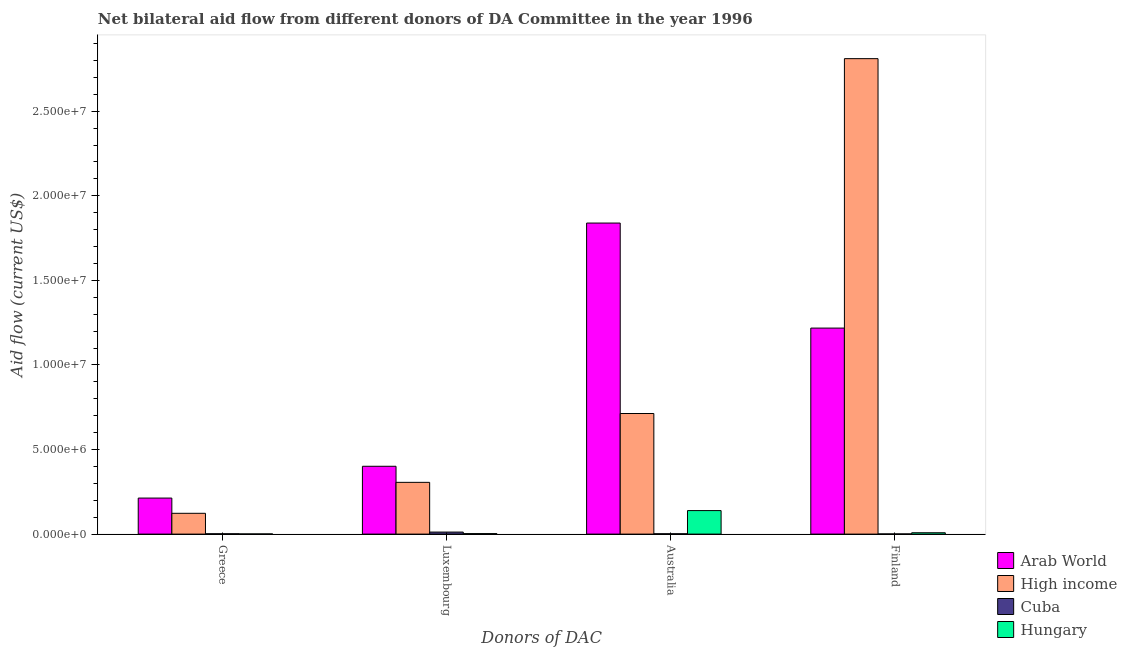Are the number of bars on each tick of the X-axis equal?
Your answer should be very brief. Yes. How many bars are there on the 3rd tick from the right?
Offer a very short reply. 4. What is the label of the 4th group of bars from the left?
Make the answer very short. Finland. What is the amount of aid given by australia in Hungary?
Provide a succinct answer. 1.39e+06. Across all countries, what is the maximum amount of aid given by luxembourg?
Your response must be concise. 4.01e+06. Across all countries, what is the minimum amount of aid given by finland?
Your answer should be compact. 10000. In which country was the amount of aid given by australia maximum?
Offer a terse response. Arab World. In which country was the amount of aid given by australia minimum?
Offer a terse response. Cuba. What is the total amount of aid given by greece in the graph?
Ensure brevity in your answer.  3.39e+06. What is the difference between the amount of aid given by finland in Arab World and that in Hungary?
Your response must be concise. 1.21e+07. What is the difference between the amount of aid given by australia in Cuba and the amount of aid given by greece in High income?
Offer a very short reply. -1.21e+06. What is the average amount of aid given by luxembourg per country?
Provide a short and direct response. 1.80e+06. What is the difference between the amount of aid given by luxembourg and amount of aid given by greece in Arab World?
Provide a short and direct response. 1.88e+06. What is the ratio of the amount of aid given by australia in High income to that in Cuba?
Provide a succinct answer. 356.5. Is the difference between the amount of aid given by finland in Hungary and High income greater than the difference between the amount of aid given by greece in Hungary and High income?
Provide a succinct answer. No. What is the difference between the highest and the second highest amount of aid given by finland?
Provide a succinct answer. 1.59e+07. What is the difference between the highest and the lowest amount of aid given by finland?
Your answer should be very brief. 2.81e+07. In how many countries, is the amount of aid given by greece greater than the average amount of aid given by greece taken over all countries?
Your answer should be compact. 2. Is the sum of the amount of aid given by australia in Arab World and Hungary greater than the maximum amount of aid given by greece across all countries?
Provide a short and direct response. Yes. Is it the case that in every country, the sum of the amount of aid given by luxembourg and amount of aid given by australia is greater than the sum of amount of aid given by greece and amount of aid given by finland?
Ensure brevity in your answer.  No. What does the 4th bar from the right in Finland represents?
Your response must be concise. Arab World. Is it the case that in every country, the sum of the amount of aid given by greece and amount of aid given by luxembourg is greater than the amount of aid given by australia?
Your answer should be very brief. No. How many bars are there?
Offer a terse response. 16. Are all the bars in the graph horizontal?
Your answer should be very brief. No. Does the graph contain grids?
Make the answer very short. No. Where does the legend appear in the graph?
Your answer should be very brief. Bottom right. How are the legend labels stacked?
Your response must be concise. Vertical. What is the title of the graph?
Give a very brief answer. Net bilateral aid flow from different donors of DA Committee in the year 1996. What is the label or title of the X-axis?
Ensure brevity in your answer.  Donors of DAC. What is the label or title of the Y-axis?
Give a very brief answer. Aid flow (current US$). What is the Aid flow (current US$) in Arab World in Greece?
Give a very brief answer. 2.13e+06. What is the Aid flow (current US$) of High income in Greece?
Your answer should be very brief. 1.23e+06. What is the Aid flow (current US$) in Hungary in Greece?
Your answer should be compact. 10000. What is the Aid flow (current US$) of Arab World in Luxembourg?
Give a very brief answer. 4.01e+06. What is the Aid flow (current US$) in High income in Luxembourg?
Ensure brevity in your answer.  3.06e+06. What is the Aid flow (current US$) of Cuba in Luxembourg?
Make the answer very short. 1.20e+05. What is the Aid flow (current US$) in Arab World in Australia?
Ensure brevity in your answer.  1.84e+07. What is the Aid flow (current US$) in High income in Australia?
Your answer should be compact. 7.13e+06. What is the Aid flow (current US$) in Hungary in Australia?
Offer a terse response. 1.39e+06. What is the Aid flow (current US$) of Arab World in Finland?
Provide a short and direct response. 1.22e+07. What is the Aid flow (current US$) of High income in Finland?
Your answer should be compact. 2.81e+07. What is the Aid flow (current US$) in Cuba in Finland?
Offer a terse response. 10000. What is the Aid flow (current US$) in Hungary in Finland?
Provide a short and direct response. 8.00e+04. Across all Donors of DAC, what is the maximum Aid flow (current US$) in Arab World?
Your answer should be compact. 1.84e+07. Across all Donors of DAC, what is the maximum Aid flow (current US$) in High income?
Make the answer very short. 2.81e+07. Across all Donors of DAC, what is the maximum Aid flow (current US$) in Hungary?
Your answer should be compact. 1.39e+06. Across all Donors of DAC, what is the minimum Aid flow (current US$) of Arab World?
Your response must be concise. 2.13e+06. Across all Donors of DAC, what is the minimum Aid flow (current US$) of High income?
Provide a succinct answer. 1.23e+06. Across all Donors of DAC, what is the minimum Aid flow (current US$) in Cuba?
Give a very brief answer. 10000. What is the total Aid flow (current US$) of Arab World in the graph?
Your answer should be compact. 3.67e+07. What is the total Aid flow (current US$) of High income in the graph?
Your response must be concise. 3.95e+07. What is the total Aid flow (current US$) of Hungary in the graph?
Your answer should be compact. 1.51e+06. What is the difference between the Aid flow (current US$) in Arab World in Greece and that in Luxembourg?
Keep it short and to the point. -1.88e+06. What is the difference between the Aid flow (current US$) of High income in Greece and that in Luxembourg?
Your answer should be very brief. -1.83e+06. What is the difference between the Aid flow (current US$) of Cuba in Greece and that in Luxembourg?
Your answer should be compact. -1.00e+05. What is the difference between the Aid flow (current US$) in Hungary in Greece and that in Luxembourg?
Offer a very short reply. -2.00e+04. What is the difference between the Aid flow (current US$) in Arab World in Greece and that in Australia?
Give a very brief answer. -1.63e+07. What is the difference between the Aid flow (current US$) of High income in Greece and that in Australia?
Give a very brief answer. -5.90e+06. What is the difference between the Aid flow (current US$) in Hungary in Greece and that in Australia?
Ensure brevity in your answer.  -1.38e+06. What is the difference between the Aid flow (current US$) of Arab World in Greece and that in Finland?
Offer a terse response. -1.00e+07. What is the difference between the Aid flow (current US$) of High income in Greece and that in Finland?
Your response must be concise. -2.69e+07. What is the difference between the Aid flow (current US$) in Arab World in Luxembourg and that in Australia?
Provide a succinct answer. -1.44e+07. What is the difference between the Aid flow (current US$) in High income in Luxembourg and that in Australia?
Offer a terse response. -4.07e+06. What is the difference between the Aid flow (current US$) in Cuba in Luxembourg and that in Australia?
Keep it short and to the point. 1.00e+05. What is the difference between the Aid flow (current US$) of Hungary in Luxembourg and that in Australia?
Provide a short and direct response. -1.36e+06. What is the difference between the Aid flow (current US$) in Arab World in Luxembourg and that in Finland?
Offer a terse response. -8.17e+06. What is the difference between the Aid flow (current US$) of High income in Luxembourg and that in Finland?
Give a very brief answer. -2.50e+07. What is the difference between the Aid flow (current US$) in Cuba in Luxembourg and that in Finland?
Give a very brief answer. 1.10e+05. What is the difference between the Aid flow (current US$) of Arab World in Australia and that in Finland?
Keep it short and to the point. 6.21e+06. What is the difference between the Aid flow (current US$) of High income in Australia and that in Finland?
Offer a very short reply. -2.10e+07. What is the difference between the Aid flow (current US$) of Cuba in Australia and that in Finland?
Offer a terse response. 10000. What is the difference between the Aid flow (current US$) in Hungary in Australia and that in Finland?
Offer a terse response. 1.31e+06. What is the difference between the Aid flow (current US$) in Arab World in Greece and the Aid flow (current US$) in High income in Luxembourg?
Your answer should be very brief. -9.30e+05. What is the difference between the Aid flow (current US$) in Arab World in Greece and the Aid flow (current US$) in Cuba in Luxembourg?
Provide a short and direct response. 2.01e+06. What is the difference between the Aid flow (current US$) of Arab World in Greece and the Aid flow (current US$) of Hungary in Luxembourg?
Your response must be concise. 2.10e+06. What is the difference between the Aid flow (current US$) in High income in Greece and the Aid flow (current US$) in Cuba in Luxembourg?
Make the answer very short. 1.11e+06. What is the difference between the Aid flow (current US$) in High income in Greece and the Aid flow (current US$) in Hungary in Luxembourg?
Keep it short and to the point. 1.20e+06. What is the difference between the Aid flow (current US$) of Cuba in Greece and the Aid flow (current US$) of Hungary in Luxembourg?
Make the answer very short. -10000. What is the difference between the Aid flow (current US$) in Arab World in Greece and the Aid flow (current US$) in High income in Australia?
Your response must be concise. -5.00e+06. What is the difference between the Aid flow (current US$) of Arab World in Greece and the Aid flow (current US$) of Cuba in Australia?
Make the answer very short. 2.11e+06. What is the difference between the Aid flow (current US$) of Arab World in Greece and the Aid flow (current US$) of Hungary in Australia?
Offer a terse response. 7.40e+05. What is the difference between the Aid flow (current US$) of High income in Greece and the Aid flow (current US$) of Cuba in Australia?
Your answer should be compact. 1.21e+06. What is the difference between the Aid flow (current US$) in Cuba in Greece and the Aid flow (current US$) in Hungary in Australia?
Provide a short and direct response. -1.37e+06. What is the difference between the Aid flow (current US$) in Arab World in Greece and the Aid flow (current US$) in High income in Finland?
Provide a short and direct response. -2.60e+07. What is the difference between the Aid flow (current US$) in Arab World in Greece and the Aid flow (current US$) in Cuba in Finland?
Offer a terse response. 2.12e+06. What is the difference between the Aid flow (current US$) in Arab World in Greece and the Aid flow (current US$) in Hungary in Finland?
Keep it short and to the point. 2.05e+06. What is the difference between the Aid flow (current US$) in High income in Greece and the Aid flow (current US$) in Cuba in Finland?
Offer a terse response. 1.22e+06. What is the difference between the Aid flow (current US$) of High income in Greece and the Aid flow (current US$) of Hungary in Finland?
Offer a very short reply. 1.15e+06. What is the difference between the Aid flow (current US$) in Arab World in Luxembourg and the Aid flow (current US$) in High income in Australia?
Give a very brief answer. -3.12e+06. What is the difference between the Aid flow (current US$) of Arab World in Luxembourg and the Aid flow (current US$) of Cuba in Australia?
Offer a very short reply. 3.99e+06. What is the difference between the Aid flow (current US$) of Arab World in Luxembourg and the Aid flow (current US$) of Hungary in Australia?
Offer a terse response. 2.62e+06. What is the difference between the Aid flow (current US$) of High income in Luxembourg and the Aid flow (current US$) of Cuba in Australia?
Keep it short and to the point. 3.04e+06. What is the difference between the Aid flow (current US$) of High income in Luxembourg and the Aid flow (current US$) of Hungary in Australia?
Make the answer very short. 1.67e+06. What is the difference between the Aid flow (current US$) in Cuba in Luxembourg and the Aid flow (current US$) in Hungary in Australia?
Offer a terse response. -1.27e+06. What is the difference between the Aid flow (current US$) of Arab World in Luxembourg and the Aid flow (current US$) of High income in Finland?
Make the answer very short. -2.41e+07. What is the difference between the Aid flow (current US$) in Arab World in Luxembourg and the Aid flow (current US$) in Cuba in Finland?
Provide a succinct answer. 4.00e+06. What is the difference between the Aid flow (current US$) in Arab World in Luxembourg and the Aid flow (current US$) in Hungary in Finland?
Ensure brevity in your answer.  3.93e+06. What is the difference between the Aid flow (current US$) of High income in Luxembourg and the Aid flow (current US$) of Cuba in Finland?
Ensure brevity in your answer.  3.05e+06. What is the difference between the Aid flow (current US$) in High income in Luxembourg and the Aid flow (current US$) in Hungary in Finland?
Ensure brevity in your answer.  2.98e+06. What is the difference between the Aid flow (current US$) in Arab World in Australia and the Aid flow (current US$) in High income in Finland?
Your answer should be compact. -9.72e+06. What is the difference between the Aid flow (current US$) of Arab World in Australia and the Aid flow (current US$) of Cuba in Finland?
Provide a short and direct response. 1.84e+07. What is the difference between the Aid flow (current US$) in Arab World in Australia and the Aid flow (current US$) in Hungary in Finland?
Provide a succinct answer. 1.83e+07. What is the difference between the Aid flow (current US$) of High income in Australia and the Aid flow (current US$) of Cuba in Finland?
Provide a short and direct response. 7.12e+06. What is the difference between the Aid flow (current US$) in High income in Australia and the Aid flow (current US$) in Hungary in Finland?
Your answer should be compact. 7.05e+06. What is the average Aid flow (current US$) in Arab World per Donors of DAC?
Provide a short and direct response. 9.18e+06. What is the average Aid flow (current US$) in High income per Donors of DAC?
Give a very brief answer. 9.88e+06. What is the average Aid flow (current US$) in Cuba per Donors of DAC?
Make the answer very short. 4.25e+04. What is the average Aid flow (current US$) in Hungary per Donors of DAC?
Make the answer very short. 3.78e+05. What is the difference between the Aid flow (current US$) of Arab World and Aid flow (current US$) of High income in Greece?
Your answer should be very brief. 9.00e+05. What is the difference between the Aid flow (current US$) of Arab World and Aid flow (current US$) of Cuba in Greece?
Your response must be concise. 2.11e+06. What is the difference between the Aid flow (current US$) in Arab World and Aid flow (current US$) in Hungary in Greece?
Provide a succinct answer. 2.12e+06. What is the difference between the Aid flow (current US$) of High income and Aid flow (current US$) of Cuba in Greece?
Ensure brevity in your answer.  1.21e+06. What is the difference between the Aid flow (current US$) in High income and Aid flow (current US$) in Hungary in Greece?
Your answer should be very brief. 1.22e+06. What is the difference between the Aid flow (current US$) in Cuba and Aid flow (current US$) in Hungary in Greece?
Make the answer very short. 10000. What is the difference between the Aid flow (current US$) of Arab World and Aid flow (current US$) of High income in Luxembourg?
Provide a short and direct response. 9.50e+05. What is the difference between the Aid flow (current US$) in Arab World and Aid flow (current US$) in Cuba in Luxembourg?
Ensure brevity in your answer.  3.89e+06. What is the difference between the Aid flow (current US$) in Arab World and Aid flow (current US$) in Hungary in Luxembourg?
Your answer should be compact. 3.98e+06. What is the difference between the Aid flow (current US$) in High income and Aid flow (current US$) in Cuba in Luxembourg?
Provide a short and direct response. 2.94e+06. What is the difference between the Aid flow (current US$) of High income and Aid flow (current US$) of Hungary in Luxembourg?
Your response must be concise. 3.03e+06. What is the difference between the Aid flow (current US$) of Arab World and Aid flow (current US$) of High income in Australia?
Give a very brief answer. 1.13e+07. What is the difference between the Aid flow (current US$) in Arab World and Aid flow (current US$) in Cuba in Australia?
Keep it short and to the point. 1.84e+07. What is the difference between the Aid flow (current US$) of Arab World and Aid flow (current US$) of Hungary in Australia?
Ensure brevity in your answer.  1.70e+07. What is the difference between the Aid flow (current US$) in High income and Aid flow (current US$) in Cuba in Australia?
Make the answer very short. 7.11e+06. What is the difference between the Aid flow (current US$) of High income and Aid flow (current US$) of Hungary in Australia?
Offer a very short reply. 5.74e+06. What is the difference between the Aid flow (current US$) in Cuba and Aid flow (current US$) in Hungary in Australia?
Your answer should be very brief. -1.37e+06. What is the difference between the Aid flow (current US$) in Arab World and Aid flow (current US$) in High income in Finland?
Provide a succinct answer. -1.59e+07. What is the difference between the Aid flow (current US$) in Arab World and Aid flow (current US$) in Cuba in Finland?
Ensure brevity in your answer.  1.22e+07. What is the difference between the Aid flow (current US$) in Arab World and Aid flow (current US$) in Hungary in Finland?
Provide a succinct answer. 1.21e+07. What is the difference between the Aid flow (current US$) in High income and Aid flow (current US$) in Cuba in Finland?
Give a very brief answer. 2.81e+07. What is the difference between the Aid flow (current US$) in High income and Aid flow (current US$) in Hungary in Finland?
Your answer should be very brief. 2.80e+07. What is the ratio of the Aid flow (current US$) of Arab World in Greece to that in Luxembourg?
Offer a terse response. 0.53. What is the ratio of the Aid flow (current US$) of High income in Greece to that in Luxembourg?
Your response must be concise. 0.4. What is the ratio of the Aid flow (current US$) of Cuba in Greece to that in Luxembourg?
Your answer should be compact. 0.17. What is the ratio of the Aid flow (current US$) in Arab World in Greece to that in Australia?
Provide a succinct answer. 0.12. What is the ratio of the Aid flow (current US$) of High income in Greece to that in Australia?
Keep it short and to the point. 0.17. What is the ratio of the Aid flow (current US$) of Cuba in Greece to that in Australia?
Offer a terse response. 1. What is the ratio of the Aid flow (current US$) of Hungary in Greece to that in Australia?
Keep it short and to the point. 0.01. What is the ratio of the Aid flow (current US$) in Arab World in Greece to that in Finland?
Make the answer very short. 0.17. What is the ratio of the Aid flow (current US$) in High income in Greece to that in Finland?
Make the answer very short. 0.04. What is the ratio of the Aid flow (current US$) of Cuba in Greece to that in Finland?
Make the answer very short. 2. What is the ratio of the Aid flow (current US$) of Arab World in Luxembourg to that in Australia?
Your answer should be very brief. 0.22. What is the ratio of the Aid flow (current US$) of High income in Luxembourg to that in Australia?
Your answer should be compact. 0.43. What is the ratio of the Aid flow (current US$) in Hungary in Luxembourg to that in Australia?
Provide a short and direct response. 0.02. What is the ratio of the Aid flow (current US$) in Arab World in Luxembourg to that in Finland?
Provide a short and direct response. 0.33. What is the ratio of the Aid flow (current US$) in High income in Luxembourg to that in Finland?
Provide a short and direct response. 0.11. What is the ratio of the Aid flow (current US$) in Cuba in Luxembourg to that in Finland?
Ensure brevity in your answer.  12. What is the ratio of the Aid flow (current US$) in Hungary in Luxembourg to that in Finland?
Your answer should be compact. 0.38. What is the ratio of the Aid flow (current US$) of Arab World in Australia to that in Finland?
Offer a terse response. 1.51. What is the ratio of the Aid flow (current US$) of High income in Australia to that in Finland?
Your answer should be very brief. 0.25. What is the ratio of the Aid flow (current US$) of Hungary in Australia to that in Finland?
Offer a very short reply. 17.38. What is the difference between the highest and the second highest Aid flow (current US$) of Arab World?
Your answer should be very brief. 6.21e+06. What is the difference between the highest and the second highest Aid flow (current US$) of High income?
Offer a very short reply. 2.10e+07. What is the difference between the highest and the second highest Aid flow (current US$) of Hungary?
Provide a short and direct response. 1.31e+06. What is the difference between the highest and the lowest Aid flow (current US$) in Arab World?
Your answer should be compact. 1.63e+07. What is the difference between the highest and the lowest Aid flow (current US$) in High income?
Provide a succinct answer. 2.69e+07. What is the difference between the highest and the lowest Aid flow (current US$) in Hungary?
Offer a very short reply. 1.38e+06. 